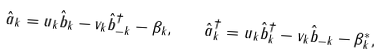Convert formula to latex. <formula><loc_0><loc_0><loc_500><loc_500>\hat { a } _ { k } = u _ { k } \hat { b } _ { k } - v _ { k } \hat { b } _ { - k } ^ { \dagger } - \beta _ { k } , \quad \hat { a } _ { k } ^ { \dagger } = u _ { k } \hat { b } _ { k } ^ { \dagger } - v _ { k } \hat { b } _ { - k } - \beta _ { k } ^ { * } ,</formula> 